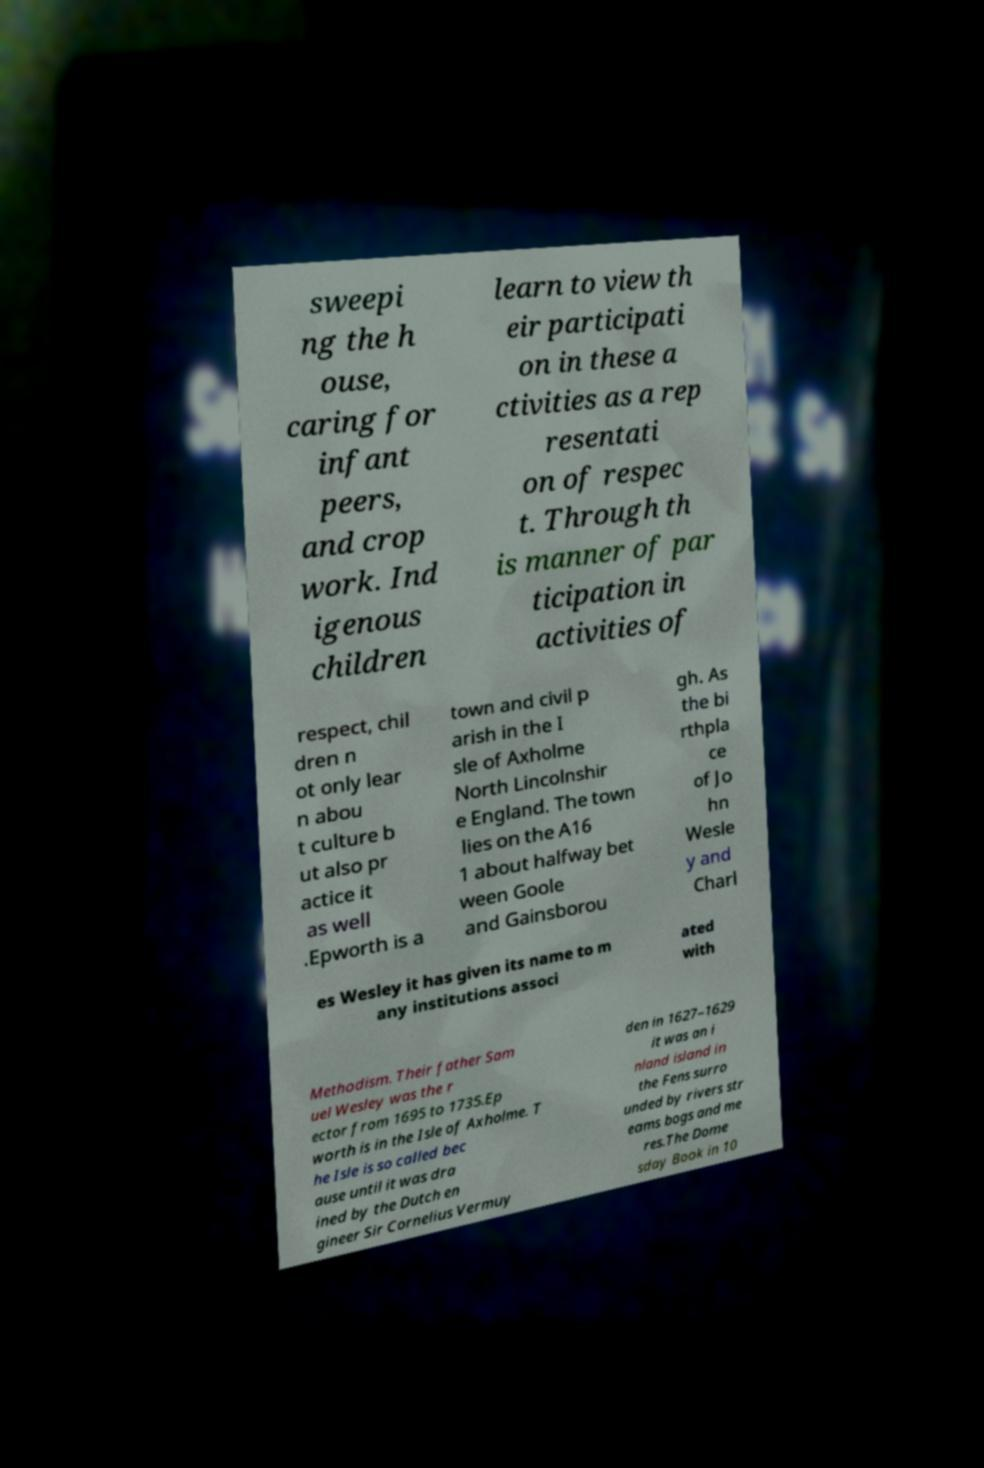Could you extract and type out the text from this image? sweepi ng the h ouse, caring for infant peers, and crop work. Ind igenous children learn to view th eir participati on in these a ctivities as a rep resentati on of respec t. Through th is manner of par ticipation in activities of respect, chil dren n ot only lear n abou t culture b ut also pr actice it as well .Epworth is a town and civil p arish in the I sle of Axholme North Lincolnshir e England. The town lies on the A16 1 about halfway bet ween Goole and Gainsborou gh. As the bi rthpla ce of Jo hn Wesle y and Charl es Wesley it has given its name to m any institutions associ ated with Methodism. Their father Sam uel Wesley was the r ector from 1695 to 1735.Ep worth is in the Isle of Axholme. T he Isle is so called bec ause until it was dra ined by the Dutch en gineer Sir Cornelius Vermuy den in 1627–1629 it was an i nland island in the Fens surro unded by rivers str eams bogs and me res.The Dome sday Book in 10 